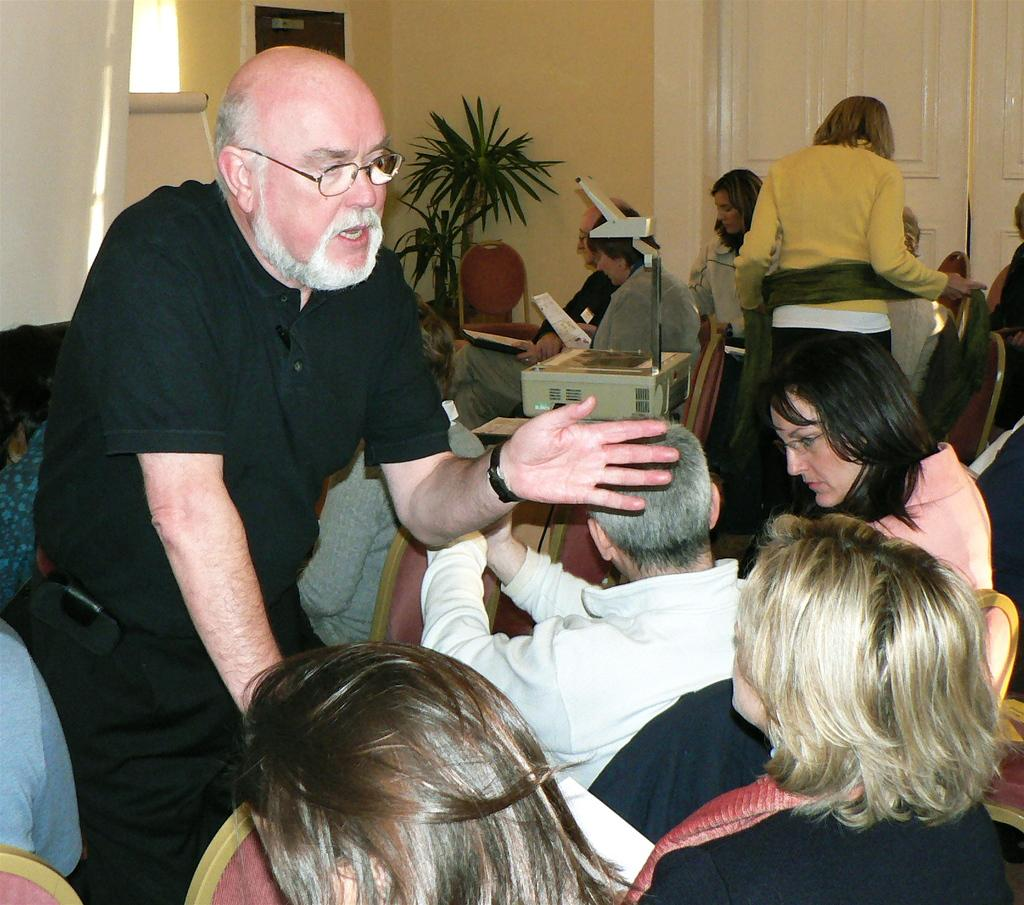What are the people in the image doing? The people in the image are sitting on chairs. Can you describe the man in the image? There is a man standing in the image. What type of vegetation is present in the image? There is a plant in the image. What is the background of the image made of? There is a wall in the image. How many doors can be seen in the image? There are doors visible in the image. What type of button can be seen on the plant in the image? There is no button present on the plant in the image. How many feathers are visible on the man in the image? There are no feathers visible on the man in the image. 